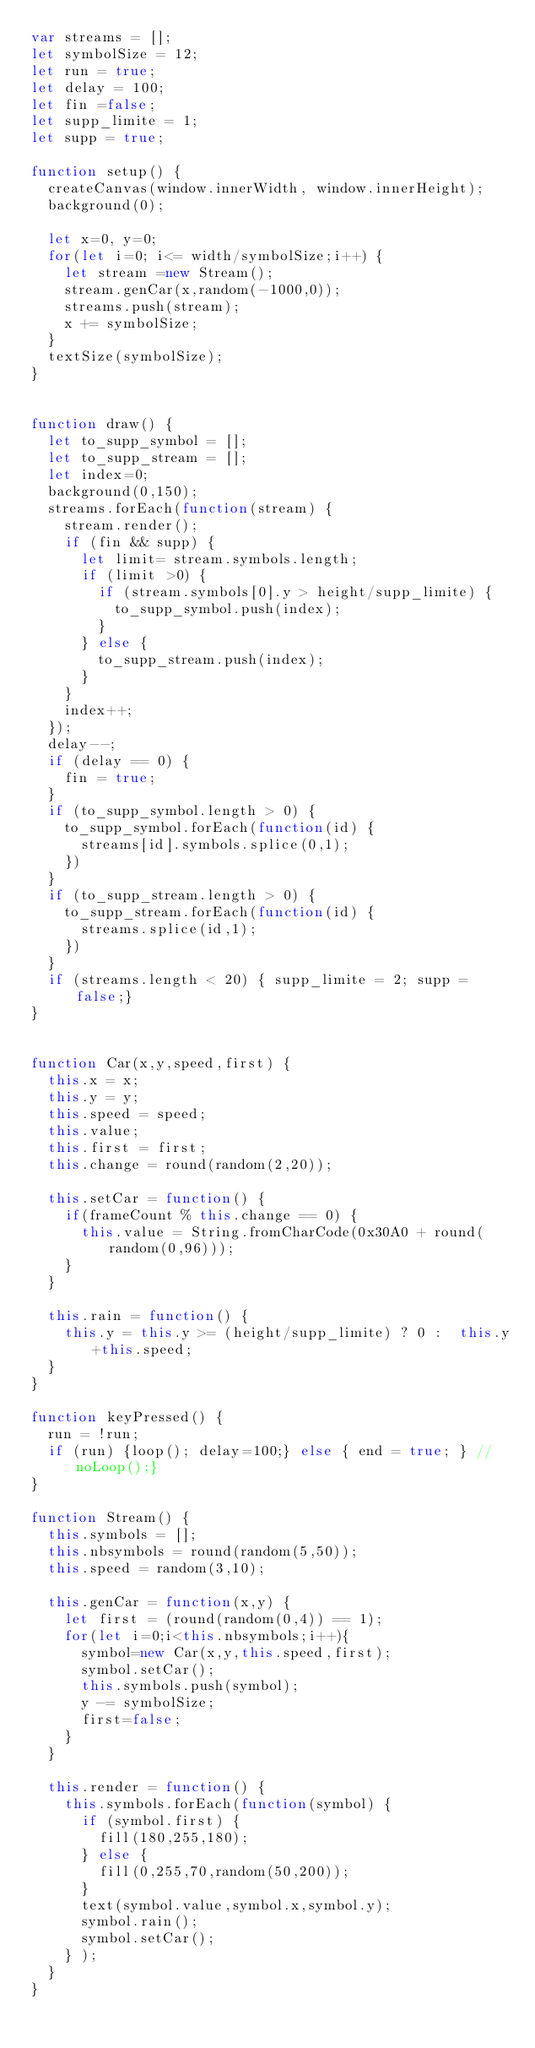<code> <loc_0><loc_0><loc_500><loc_500><_JavaScript_>var streams = [];
let symbolSize = 12;
let run = true;
let delay = 100;
let fin =false;
let supp_limite = 1;
let supp = true;

function setup() {
	createCanvas(window.innerWidth, window.innerHeight);
	background(0);

	let x=0, y=0;
	for(let i=0; i<= width/symbolSize;i++) {
		let stream =new Stream();
		stream.genCar(x,random(-1000,0));
		streams.push(stream);
		x += symbolSize;
	}
	textSize(symbolSize);
}


function draw() {
	let to_supp_symbol = [];
	let to_supp_stream = [];
	let index=0;
	background(0,150);
	streams.forEach(function(stream) {
		stream.render();
		if (fin && supp) {
			let limit= stream.symbols.length;
			if (limit >0) {
				if (stream.symbols[0].y > height/supp_limite) {
					to_supp_symbol.push(index);
				} 
			} else { 
				to_supp_stream.push(index);
			}
		}
		index++;
	});
	delay--;
	if (delay == 0) {
		fin = true;
	}
	if (to_supp_symbol.length > 0) {
		to_supp_symbol.forEach(function(id) {
			streams[id].symbols.splice(0,1);
		})
	}
	if (to_supp_stream.length > 0) {
		to_supp_stream.forEach(function(id) {
			streams.splice(id,1);
		})
	}
	if (streams.length < 20) { supp_limite = 2; supp = false;}
}


function Car(x,y,speed,first) {
	this.x = x;
	this.y = y;
	this.speed = speed;
	this.value;
	this.first = first;
	this.change = round(random(2,20));

	this.setCar = function() {
		if(frameCount % this.change == 0) {
			this.value = String.fromCharCode(0x30A0 + round(random(0,96)));
		}
	}

	this.rain = function() {
		this.y = this.y >= (height/supp_limite) ? 0 :  this.y+this.speed;
	}
}

function keyPressed() {
	run = !run;
	if (run) {loop(); delay=100;} else { end = true; } //noLoop();}
}

function Stream() {
	this.symbols = [];
	this.nbsymbols = round(random(5,50));
	this.speed = random(3,10);

	this.genCar = function(x,y) {
		let first = (round(random(0,4)) == 1);
		for(let i=0;i<this.nbsymbols;i++){
			symbol=new Car(x,y,this.speed,first);
			symbol.setCar();
			this.symbols.push(symbol);
			y -= symbolSize;
			first=false;
		}
	}

	this.render = function() {
		this.symbols.forEach(function(symbol) {
			if (symbol.first) {
				fill(180,255,180);
			} else {
				fill(0,255,70,random(50,200));
			}
			text(symbol.value,symbol.x,symbol.y);
			symbol.rain();
			symbol.setCar();
		} );
	}
}</code> 